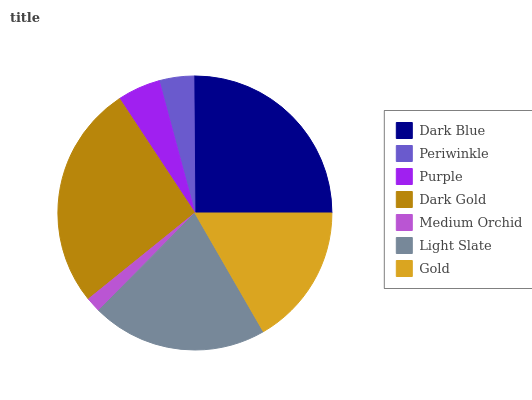Is Medium Orchid the minimum?
Answer yes or no. Yes. Is Dark Gold the maximum?
Answer yes or no. Yes. Is Periwinkle the minimum?
Answer yes or no. No. Is Periwinkle the maximum?
Answer yes or no. No. Is Dark Blue greater than Periwinkle?
Answer yes or no. Yes. Is Periwinkle less than Dark Blue?
Answer yes or no. Yes. Is Periwinkle greater than Dark Blue?
Answer yes or no. No. Is Dark Blue less than Periwinkle?
Answer yes or no. No. Is Gold the high median?
Answer yes or no. Yes. Is Gold the low median?
Answer yes or no. Yes. Is Dark Blue the high median?
Answer yes or no. No. Is Purple the low median?
Answer yes or no. No. 